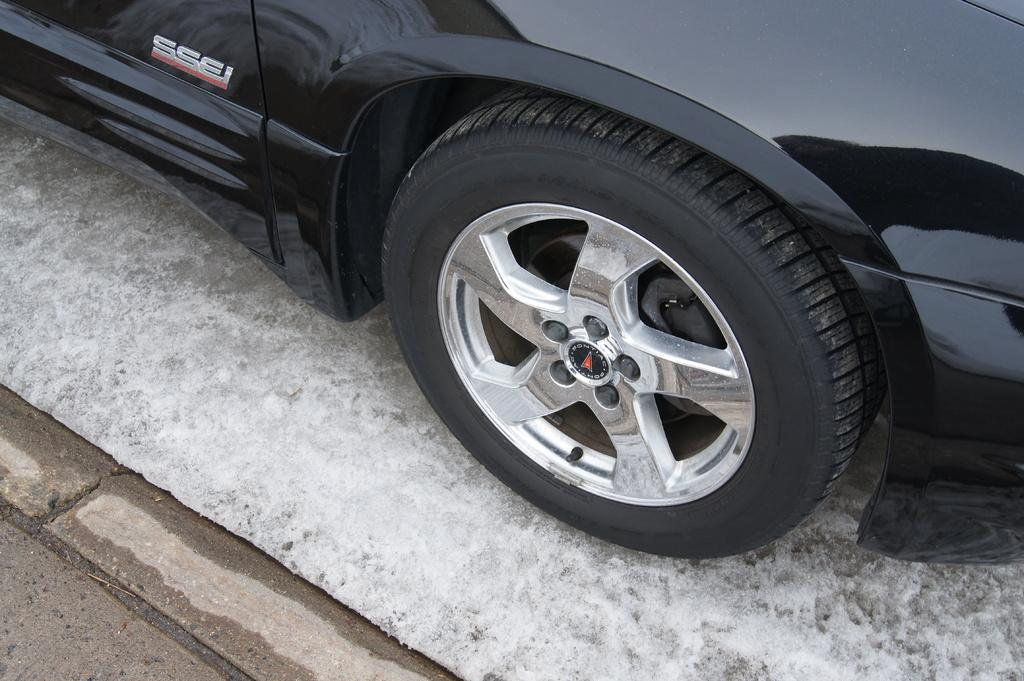What is the main subject of the image? There is a car in the image. What color is the car? The car is black in color. What can be seen at the bottom of the image? There is a road visible at the bottom of the image. How many trees are growing in a circle around the car in the image? There are no trees present in the image, and therefore no trees are growing in a circle around the car. 